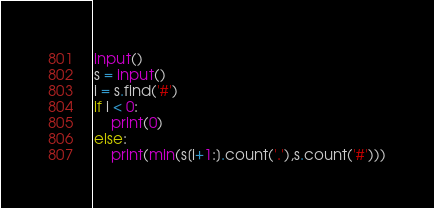<code> <loc_0><loc_0><loc_500><loc_500><_Python_>input()
s = input()
i = s.find('#')
if i < 0:
    print(0)
else:
    print(min(s[i+1:].count('.'),s.count('#')))</code> 